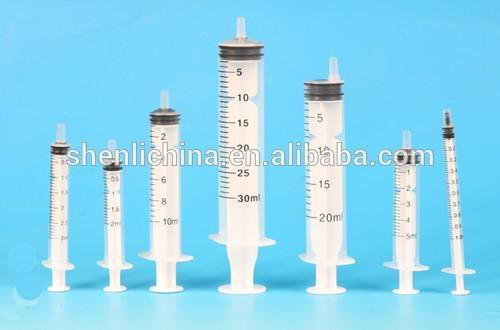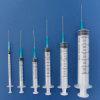The first image is the image on the left, the second image is the image on the right. Given the left and right images, does the statement "Right image shows syringes arranged big to small, with the biggest in volume on the left." hold true? Answer yes or no. No. 